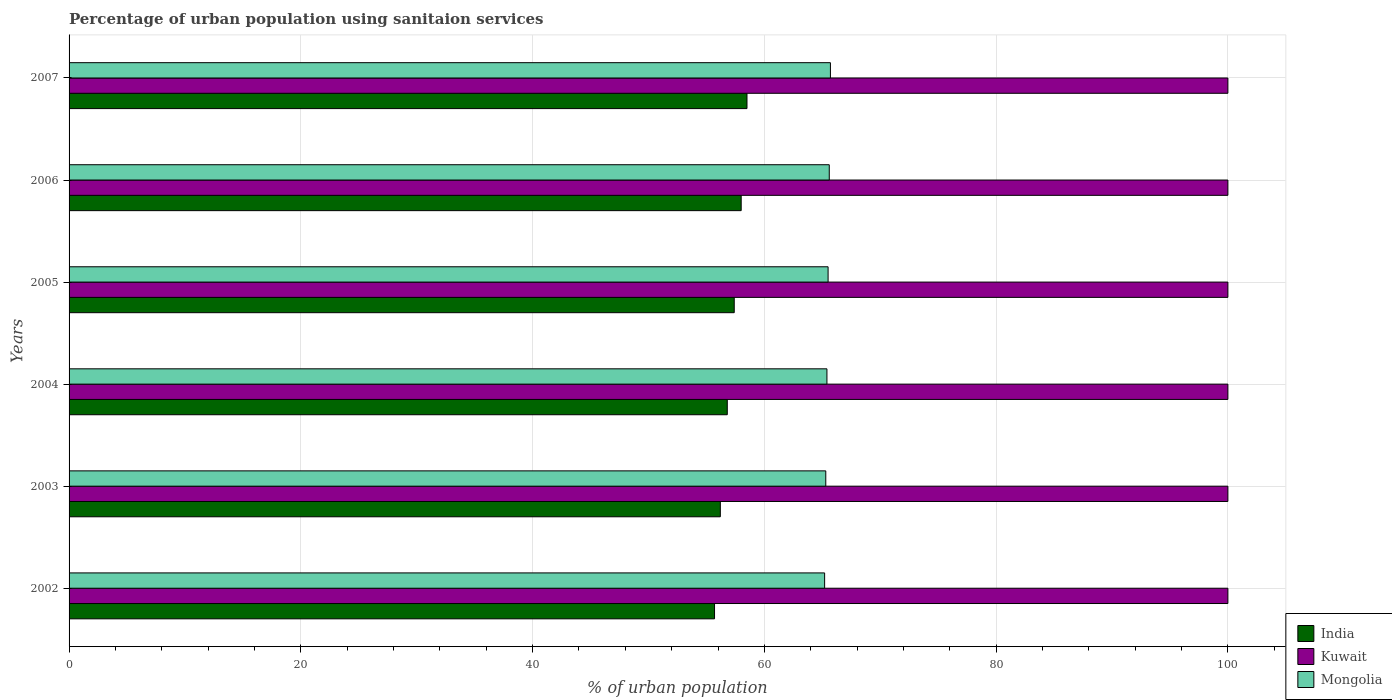How many different coloured bars are there?
Your answer should be very brief. 3. Are the number of bars on each tick of the Y-axis equal?
Offer a very short reply. Yes. How many bars are there on the 4th tick from the top?
Ensure brevity in your answer.  3. How many bars are there on the 2nd tick from the bottom?
Give a very brief answer. 3. What is the percentage of urban population using sanitaion services in India in 2002?
Provide a succinct answer. 55.7. Across all years, what is the maximum percentage of urban population using sanitaion services in Kuwait?
Keep it short and to the point. 100. Across all years, what is the minimum percentage of urban population using sanitaion services in Kuwait?
Provide a short and direct response. 100. In which year was the percentage of urban population using sanitaion services in Mongolia maximum?
Give a very brief answer. 2007. What is the total percentage of urban population using sanitaion services in India in the graph?
Provide a succinct answer. 342.6. What is the difference between the percentage of urban population using sanitaion services in India in 2004 and that in 2007?
Ensure brevity in your answer.  -1.7. What is the difference between the percentage of urban population using sanitaion services in India in 2004 and the percentage of urban population using sanitaion services in Mongolia in 2003?
Ensure brevity in your answer.  -8.5. What is the average percentage of urban population using sanitaion services in Mongolia per year?
Offer a terse response. 65.45. In the year 2005, what is the difference between the percentage of urban population using sanitaion services in Kuwait and percentage of urban population using sanitaion services in Mongolia?
Offer a very short reply. 34.5. In how many years, is the percentage of urban population using sanitaion services in India greater than 64 %?
Keep it short and to the point. 0. What is the ratio of the percentage of urban population using sanitaion services in India in 2002 to that in 2006?
Give a very brief answer. 0.96. Is the percentage of urban population using sanitaion services in Kuwait in 2002 less than that in 2007?
Offer a very short reply. No. What is the difference between the highest and the second highest percentage of urban population using sanitaion services in Mongolia?
Your answer should be compact. 0.1. What is the difference between the highest and the lowest percentage of urban population using sanitaion services in India?
Offer a terse response. 2.8. In how many years, is the percentage of urban population using sanitaion services in India greater than the average percentage of urban population using sanitaion services in India taken over all years?
Make the answer very short. 3. What does the 1st bar from the top in 2007 represents?
Make the answer very short. Mongolia. How many bars are there?
Offer a very short reply. 18. How many years are there in the graph?
Provide a succinct answer. 6. What is the difference between two consecutive major ticks on the X-axis?
Make the answer very short. 20. Are the values on the major ticks of X-axis written in scientific E-notation?
Ensure brevity in your answer.  No. Does the graph contain grids?
Your answer should be compact. Yes. Where does the legend appear in the graph?
Offer a very short reply. Bottom right. How are the legend labels stacked?
Your answer should be very brief. Vertical. What is the title of the graph?
Offer a very short reply. Percentage of urban population using sanitaion services. What is the label or title of the X-axis?
Your response must be concise. % of urban population. What is the label or title of the Y-axis?
Offer a very short reply. Years. What is the % of urban population of India in 2002?
Give a very brief answer. 55.7. What is the % of urban population of Kuwait in 2002?
Your response must be concise. 100. What is the % of urban population of Mongolia in 2002?
Ensure brevity in your answer.  65.2. What is the % of urban population in India in 2003?
Offer a very short reply. 56.2. What is the % of urban population in Kuwait in 2003?
Provide a short and direct response. 100. What is the % of urban population of Mongolia in 2003?
Offer a terse response. 65.3. What is the % of urban population in India in 2004?
Offer a very short reply. 56.8. What is the % of urban population in Kuwait in 2004?
Provide a succinct answer. 100. What is the % of urban population of Mongolia in 2004?
Offer a terse response. 65.4. What is the % of urban population of India in 2005?
Keep it short and to the point. 57.4. What is the % of urban population of Kuwait in 2005?
Keep it short and to the point. 100. What is the % of urban population of Mongolia in 2005?
Give a very brief answer. 65.5. What is the % of urban population in India in 2006?
Your response must be concise. 58. What is the % of urban population of Kuwait in 2006?
Offer a very short reply. 100. What is the % of urban population in Mongolia in 2006?
Make the answer very short. 65.6. What is the % of urban population of India in 2007?
Keep it short and to the point. 58.5. What is the % of urban population in Mongolia in 2007?
Give a very brief answer. 65.7. Across all years, what is the maximum % of urban population in India?
Your answer should be very brief. 58.5. Across all years, what is the maximum % of urban population of Kuwait?
Your answer should be very brief. 100. Across all years, what is the maximum % of urban population in Mongolia?
Keep it short and to the point. 65.7. Across all years, what is the minimum % of urban population of India?
Provide a succinct answer. 55.7. Across all years, what is the minimum % of urban population of Kuwait?
Your answer should be compact. 100. Across all years, what is the minimum % of urban population in Mongolia?
Keep it short and to the point. 65.2. What is the total % of urban population in India in the graph?
Provide a short and direct response. 342.6. What is the total % of urban population of Kuwait in the graph?
Provide a succinct answer. 600. What is the total % of urban population in Mongolia in the graph?
Ensure brevity in your answer.  392.7. What is the difference between the % of urban population of India in 2002 and that in 2003?
Offer a terse response. -0.5. What is the difference between the % of urban population of India in 2002 and that in 2004?
Provide a short and direct response. -1.1. What is the difference between the % of urban population of Kuwait in 2002 and that in 2004?
Your response must be concise. 0. What is the difference between the % of urban population of Mongolia in 2002 and that in 2004?
Your response must be concise. -0.2. What is the difference between the % of urban population in India in 2002 and that in 2005?
Your response must be concise. -1.7. What is the difference between the % of urban population in Kuwait in 2002 and that in 2005?
Your response must be concise. 0. What is the difference between the % of urban population in Mongolia in 2002 and that in 2005?
Provide a short and direct response. -0.3. What is the difference between the % of urban population of India in 2002 and that in 2006?
Give a very brief answer. -2.3. What is the difference between the % of urban population in Kuwait in 2002 and that in 2006?
Offer a very short reply. 0. What is the difference between the % of urban population of Mongolia in 2002 and that in 2006?
Keep it short and to the point. -0.4. What is the difference between the % of urban population in India in 2002 and that in 2007?
Ensure brevity in your answer.  -2.8. What is the difference between the % of urban population in Mongolia in 2002 and that in 2007?
Provide a succinct answer. -0.5. What is the difference between the % of urban population of Kuwait in 2003 and that in 2004?
Your answer should be compact. 0. What is the difference between the % of urban population of India in 2003 and that in 2005?
Provide a short and direct response. -1.2. What is the difference between the % of urban population of Kuwait in 2003 and that in 2005?
Keep it short and to the point. 0. What is the difference between the % of urban population in Mongolia in 2003 and that in 2005?
Your response must be concise. -0.2. What is the difference between the % of urban population of India in 2003 and that in 2007?
Make the answer very short. -2.3. What is the difference between the % of urban population of Mongolia in 2003 and that in 2007?
Offer a very short reply. -0.4. What is the difference between the % of urban population of Kuwait in 2004 and that in 2005?
Make the answer very short. 0. What is the difference between the % of urban population of Mongolia in 2004 and that in 2005?
Offer a very short reply. -0.1. What is the difference between the % of urban population of India in 2004 and that in 2006?
Your response must be concise. -1.2. What is the difference between the % of urban population of Kuwait in 2004 and that in 2006?
Offer a terse response. 0. What is the difference between the % of urban population in Mongolia in 2004 and that in 2006?
Provide a succinct answer. -0.2. What is the difference between the % of urban population in India in 2005 and that in 2006?
Your answer should be very brief. -0.6. What is the difference between the % of urban population of Kuwait in 2005 and that in 2006?
Ensure brevity in your answer.  0. What is the difference between the % of urban population in India in 2005 and that in 2007?
Provide a succinct answer. -1.1. What is the difference between the % of urban population of India in 2006 and that in 2007?
Give a very brief answer. -0.5. What is the difference between the % of urban population in Mongolia in 2006 and that in 2007?
Your answer should be compact. -0.1. What is the difference between the % of urban population of India in 2002 and the % of urban population of Kuwait in 2003?
Ensure brevity in your answer.  -44.3. What is the difference between the % of urban population in India in 2002 and the % of urban population in Mongolia in 2003?
Your answer should be very brief. -9.6. What is the difference between the % of urban population of Kuwait in 2002 and the % of urban population of Mongolia in 2003?
Provide a succinct answer. 34.7. What is the difference between the % of urban population in India in 2002 and the % of urban population in Kuwait in 2004?
Your response must be concise. -44.3. What is the difference between the % of urban population of India in 2002 and the % of urban population of Mongolia in 2004?
Offer a terse response. -9.7. What is the difference between the % of urban population of Kuwait in 2002 and the % of urban population of Mongolia in 2004?
Make the answer very short. 34.6. What is the difference between the % of urban population of India in 2002 and the % of urban population of Kuwait in 2005?
Offer a very short reply. -44.3. What is the difference between the % of urban population of India in 2002 and the % of urban population of Mongolia in 2005?
Your answer should be very brief. -9.8. What is the difference between the % of urban population in Kuwait in 2002 and the % of urban population in Mongolia in 2005?
Provide a short and direct response. 34.5. What is the difference between the % of urban population of India in 2002 and the % of urban population of Kuwait in 2006?
Provide a short and direct response. -44.3. What is the difference between the % of urban population of India in 2002 and the % of urban population of Mongolia in 2006?
Offer a very short reply. -9.9. What is the difference between the % of urban population in Kuwait in 2002 and the % of urban population in Mongolia in 2006?
Make the answer very short. 34.4. What is the difference between the % of urban population of India in 2002 and the % of urban population of Kuwait in 2007?
Provide a succinct answer. -44.3. What is the difference between the % of urban population of Kuwait in 2002 and the % of urban population of Mongolia in 2007?
Offer a very short reply. 34.3. What is the difference between the % of urban population in India in 2003 and the % of urban population in Kuwait in 2004?
Offer a very short reply. -43.8. What is the difference between the % of urban population of Kuwait in 2003 and the % of urban population of Mongolia in 2004?
Your response must be concise. 34.6. What is the difference between the % of urban population in India in 2003 and the % of urban population in Kuwait in 2005?
Your response must be concise. -43.8. What is the difference between the % of urban population in Kuwait in 2003 and the % of urban population in Mongolia in 2005?
Provide a succinct answer. 34.5. What is the difference between the % of urban population of India in 2003 and the % of urban population of Kuwait in 2006?
Provide a succinct answer. -43.8. What is the difference between the % of urban population in Kuwait in 2003 and the % of urban population in Mongolia in 2006?
Your answer should be very brief. 34.4. What is the difference between the % of urban population of India in 2003 and the % of urban population of Kuwait in 2007?
Ensure brevity in your answer.  -43.8. What is the difference between the % of urban population of India in 2003 and the % of urban population of Mongolia in 2007?
Provide a succinct answer. -9.5. What is the difference between the % of urban population of Kuwait in 2003 and the % of urban population of Mongolia in 2007?
Offer a terse response. 34.3. What is the difference between the % of urban population in India in 2004 and the % of urban population in Kuwait in 2005?
Keep it short and to the point. -43.2. What is the difference between the % of urban population in India in 2004 and the % of urban population in Mongolia in 2005?
Provide a short and direct response. -8.7. What is the difference between the % of urban population in Kuwait in 2004 and the % of urban population in Mongolia in 2005?
Your answer should be compact. 34.5. What is the difference between the % of urban population of India in 2004 and the % of urban population of Kuwait in 2006?
Give a very brief answer. -43.2. What is the difference between the % of urban population of Kuwait in 2004 and the % of urban population of Mongolia in 2006?
Make the answer very short. 34.4. What is the difference between the % of urban population in India in 2004 and the % of urban population in Kuwait in 2007?
Offer a terse response. -43.2. What is the difference between the % of urban population in Kuwait in 2004 and the % of urban population in Mongolia in 2007?
Your response must be concise. 34.3. What is the difference between the % of urban population of India in 2005 and the % of urban population of Kuwait in 2006?
Your answer should be compact. -42.6. What is the difference between the % of urban population in India in 2005 and the % of urban population in Mongolia in 2006?
Provide a short and direct response. -8.2. What is the difference between the % of urban population of Kuwait in 2005 and the % of urban population of Mongolia in 2006?
Ensure brevity in your answer.  34.4. What is the difference between the % of urban population in India in 2005 and the % of urban population in Kuwait in 2007?
Make the answer very short. -42.6. What is the difference between the % of urban population in Kuwait in 2005 and the % of urban population in Mongolia in 2007?
Provide a short and direct response. 34.3. What is the difference between the % of urban population in India in 2006 and the % of urban population in Kuwait in 2007?
Keep it short and to the point. -42. What is the difference between the % of urban population in India in 2006 and the % of urban population in Mongolia in 2007?
Provide a short and direct response. -7.7. What is the difference between the % of urban population in Kuwait in 2006 and the % of urban population in Mongolia in 2007?
Offer a very short reply. 34.3. What is the average % of urban population of India per year?
Make the answer very short. 57.1. What is the average % of urban population of Mongolia per year?
Make the answer very short. 65.45. In the year 2002, what is the difference between the % of urban population of India and % of urban population of Kuwait?
Ensure brevity in your answer.  -44.3. In the year 2002, what is the difference between the % of urban population in India and % of urban population in Mongolia?
Offer a very short reply. -9.5. In the year 2002, what is the difference between the % of urban population in Kuwait and % of urban population in Mongolia?
Your answer should be very brief. 34.8. In the year 2003, what is the difference between the % of urban population of India and % of urban population of Kuwait?
Offer a very short reply. -43.8. In the year 2003, what is the difference between the % of urban population in Kuwait and % of urban population in Mongolia?
Offer a very short reply. 34.7. In the year 2004, what is the difference between the % of urban population of India and % of urban population of Kuwait?
Provide a short and direct response. -43.2. In the year 2004, what is the difference between the % of urban population of Kuwait and % of urban population of Mongolia?
Your answer should be very brief. 34.6. In the year 2005, what is the difference between the % of urban population of India and % of urban population of Kuwait?
Offer a very short reply. -42.6. In the year 2005, what is the difference between the % of urban population of India and % of urban population of Mongolia?
Keep it short and to the point. -8.1. In the year 2005, what is the difference between the % of urban population in Kuwait and % of urban population in Mongolia?
Your response must be concise. 34.5. In the year 2006, what is the difference between the % of urban population of India and % of urban population of Kuwait?
Keep it short and to the point. -42. In the year 2006, what is the difference between the % of urban population in Kuwait and % of urban population in Mongolia?
Make the answer very short. 34.4. In the year 2007, what is the difference between the % of urban population of India and % of urban population of Kuwait?
Your answer should be very brief. -41.5. In the year 2007, what is the difference between the % of urban population in Kuwait and % of urban population in Mongolia?
Your answer should be compact. 34.3. What is the ratio of the % of urban population in Kuwait in 2002 to that in 2003?
Keep it short and to the point. 1. What is the ratio of the % of urban population of India in 2002 to that in 2004?
Provide a short and direct response. 0.98. What is the ratio of the % of urban population of Mongolia in 2002 to that in 2004?
Provide a short and direct response. 1. What is the ratio of the % of urban population in India in 2002 to that in 2005?
Your answer should be very brief. 0.97. What is the ratio of the % of urban population in Kuwait in 2002 to that in 2005?
Offer a terse response. 1. What is the ratio of the % of urban population of India in 2002 to that in 2006?
Your answer should be very brief. 0.96. What is the ratio of the % of urban population in Kuwait in 2002 to that in 2006?
Provide a short and direct response. 1. What is the ratio of the % of urban population of Mongolia in 2002 to that in 2006?
Make the answer very short. 0.99. What is the ratio of the % of urban population in India in 2002 to that in 2007?
Give a very brief answer. 0.95. What is the ratio of the % of urban population of Kuwait in 2002 to that in 2007?
Your response must be concise. 1. What is the ratio of the % of urban population in Kuwait in 2003 to that in 2004?
Offer a very short reply. 1. What is the ratio of the % of urban population of Mongolia in 2003 to that in 2004?
Offer a terse response. 1. What is the ratio of the % of urban population of India in 2003 to that in 2005?
Your response must be concise. 0.98. What is the ratio of the % of urban population in Kuwait in 2003 to that in 2005?
Your answer should be compact. 1. What is the ratio of the % of urban population in Mongolia in 2003 to that in 2005?
Offer a terse response. 1. What is the ratio of the % of urban population in India in 2003 to that in 2007?
Your response must be concise. 0.96. What is the ratio of the % of urban population in Kuwait in 2003 to that in 2007?
Your answer should be compact. 1. What is the ratio of the % of urban population of Mongolia in 2003 to that in 2007?
Give a very brief answer. 0.99. What is the ratio of the % of urban population in India in 2004 to that in 2005?
Your answer should be compact. 0.99. What is the ratio of the % of urban population in India in 2004 to that in 2006?
Ensure brevity in your answer.  0.98. What is the ratio of the % of urban population in India in 2004 to that in 2007?
Provide a succinct answer. 0.97. What is the ratio of the % of urban population in India in 2005 to that in 2006?
Your response must be concise. 0.99. What is the ratio of the % of urban population in Kuwait in 2005 to that in 2006?
Offer a terse response. 1. What is the ratio of the % of urban population of India in 2005 to that in 2007?
Ensure brevity in your answer.  0.98. What is the ratio of the % of urban population of Mongolia in 2005 to that in 2007?
Your answer should be very brief. 1. What is the ratio of the % of urban population of Kuwait in 2006 to that in 2007?
Your answer should be very brief. 1. What is the difference between the highest and the second highest % of urban population in India?
Offer a very short reply. 0.5. What is the difference between the highest and the second highest % of urban population in Mongolia?
Keep it short and to the point. 0.1. What is the difference between the highest and the lowest % of urban population in Mongolia?
Your answer should be very brief. 0.5. 